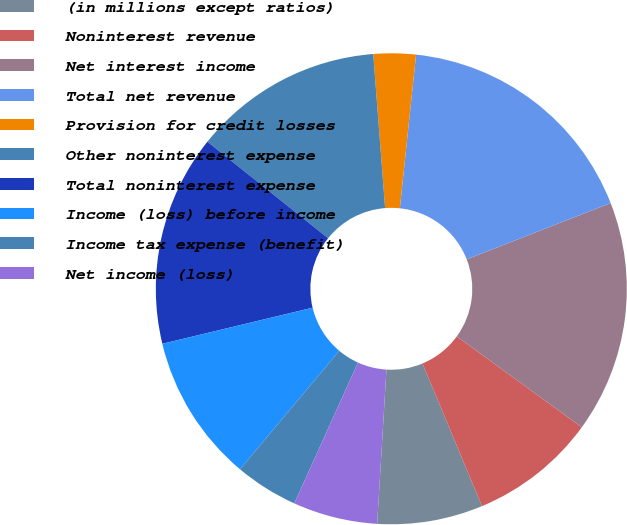<chart> <loc_0><loc_0><loc_500><loc_500><pie_chart><fcel>(in millions except ratios)<fcel>Noninterest revenue<fcel>Net interest income<fcel>Total net revenue<fcel>Provision for credit losses<fcel>Other noninterest expense<fcel>Total noninterest expense<fcel>Income (loss) before income<fcel>Income tax expense (benefit)<fcel>Net income (loss)<nl><fcel>7.25%<fcel>8.7%<fcel>15.94%<fcel>17.39%<fcel>2.9%<fcel>13.04%<fcel>14.49%<fcel>10.14%<fcel>4.35%<fcel>5.8%<nl></chart> 